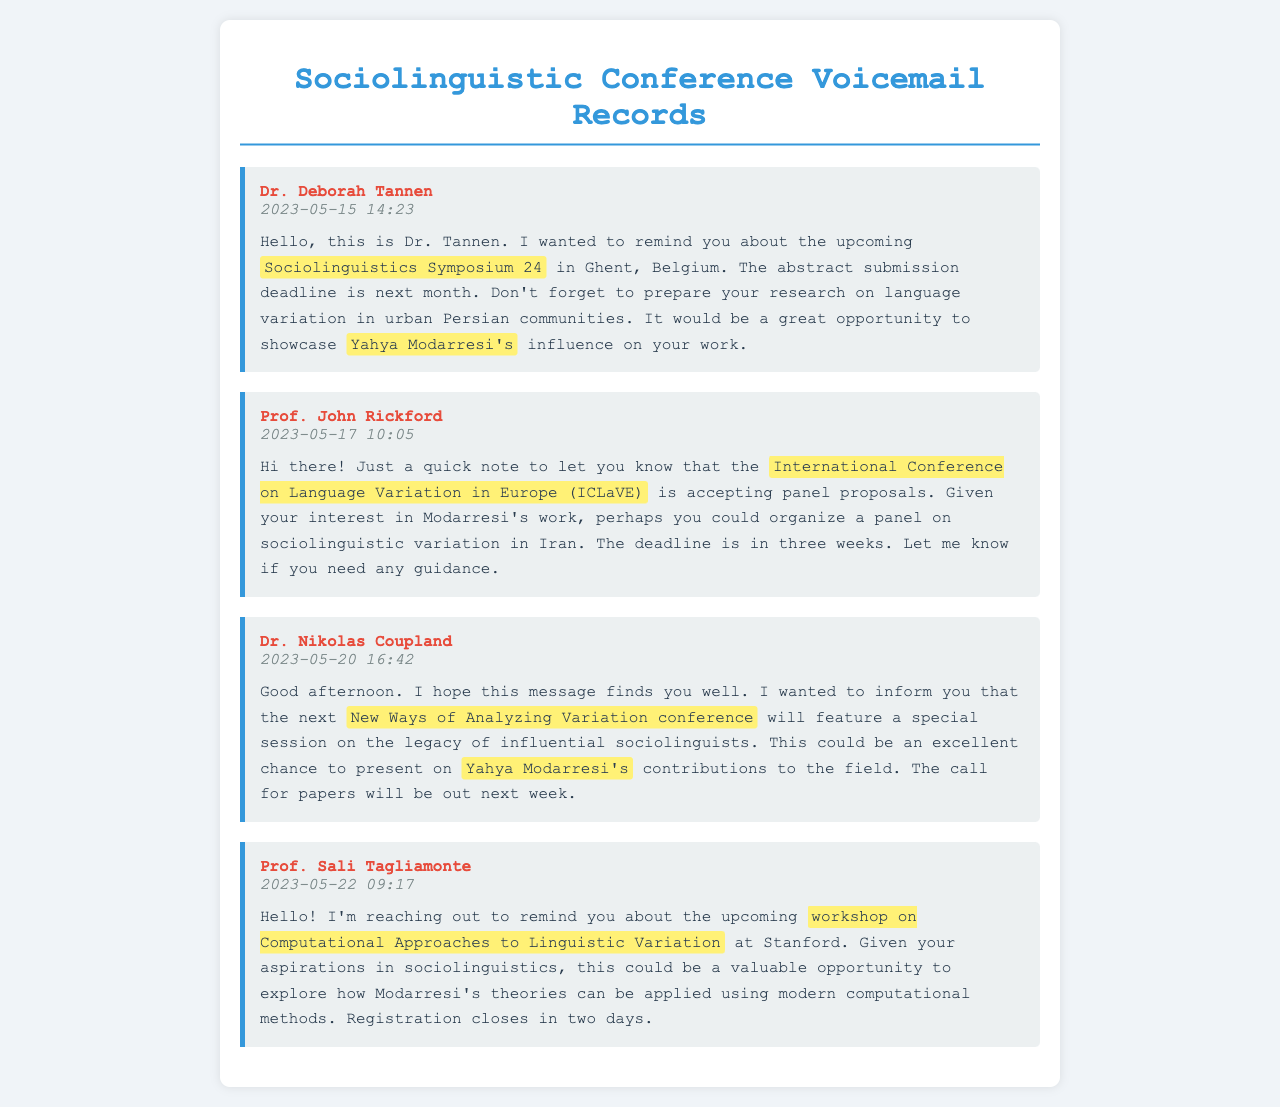What is the name of the conference in Belgium? The voicemail from Dr. Deborah Tannen mentions the upcoming conference as the Sociolinguistics Symposium 24 in Ghent, Belgium.
Answer: Sociolinguistics Symposium 24 Who left a message about ICLaVE? Prof. John Rickford is the one who left a voicemail regarding the International Conference on Language Variation in Europe (ICLaVE).
Answer: Prof. John Rickford When is the deadline for abstract submission for the Sociolinguistics Symposium 24? Dr. Tannen mentions that the abstract submission deadline is next month in her voicemail.
Answer: Next month What special session will the New Ways of Analyzing Variation conference feature? Dr. Nikolas Coupland's message discusses a special session on the legacy of influential sociolinguists.
Answer: Legacy of influential sociolinguists What is the registration status for the workshop at Stanford? Prof. Sali Tagliamonte's message states that registration closes in two days for the workshop on Computational Approaches to Linguistic Variation.
Answer: Closes in two days 